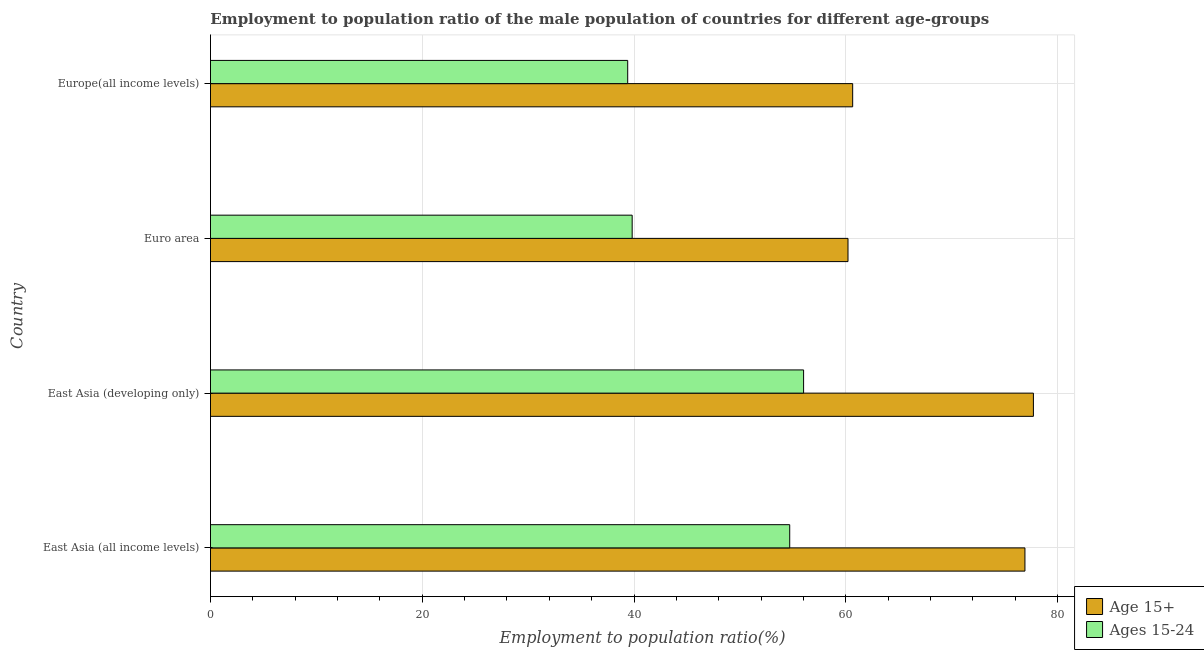How many different coloured bars are there?
Offer a very short reply. 2. Are the number of bars on each tick of the Y-axis equal?
Your answer should be very brief. Yes. How many bars are there on the 2nd tick from the bottom?
Provide a short and direct response. 2. What is the label of the 4th group of bars from the top?
Provide a succinct answer. East Asia (all income levels). In how many cases, is the number of bars for a given country not equal to the number of legend labels?
Provide a short and direct response. 0. What is the employment to population ratio(age 15+) in Euro area?
Keep it short and to the point. 60.2. Across all countries, what is the maximum employment to population ratio(age 15-24)?
Your answer should be compact. 56.01. Across all countries, what is the minimum employment to population ratio(age 15-24)?
Your response must be concise. 39.4. In which country was the employment to population ratio(age 15+) maximum?
Your response must be concise. East Asia (developing only). In which country was the employment to population ratio(age 15-24) minimum?
Offer a very short reply. Europe(all income levels). What is the total employment to population ratio(age 15-24) in the graph?
Make the answer very short. 189.93. What is the difference between the employment to population ratio(age 15+) in East Asia (all income levels) and that in Euro area?
Your answer should be compact. 16.71. What is the difference between the employment to population ratio(age 15-24) in Europe(all income levels) and the employment to population ratio(age 15+) in East Asia (all income levels)?
Ensure brevity in your answer.  -37.51. What is the average employment to population ratio(age 15-24) per country?
Your answer should be compact. 47.48. What is the difference between the employment to population ratio(age 15+) and employment to population ratio(age 15-24) in Euro area?
Provide a short and direct response. 20.38. What is the ratio of the employment to population ratio(age 15+) in East Asia (developing only) to that in Europe(all income levels)?
Provide a succinct answer. 1.28. Is the employment to population ratio(age 15-24) in East Asia (developing only) less than that in Europe(all income levels)?
Offer a terse response. No. Is the difference between the employment to population ratio(age 15+) in Euro area and Europe(all income levels) greater than the difference between the employment to population ratio(age 15-24) in Euro area and Europe(all income levels)?
Your response must be concise. No. What is the difference between the highest and the second highest employment to population ratio(age 15-24)?
Your response must be concise. 1.31. What is the difference between the highest and the lowest employment to population ratio(age 15+)?
Provide a short and direct response. 17.51. What does the 1st bar from the top in Euro area represents?
Give a very brief answer. Ages 15-24. What does the 1st bar from the bottom in Europe(all income levels) represents?
Provide a succinct answer. Age 15+. Are all the bars in the graph horizontal?
Offer a very short reply. Yes. How many countries are there in the graph?
Provide a short and direct response. 4. What is the difference between two consecutive major ticks on the X-axis?
Ensure brevity in your answer.  20. Are the values on the major ticks of X-axis written in scientific E-notation?
Your answer should be compact. No. Does the graph contain any zero values?
Offer a very short reply. No. Where does the legend appear in the graph?
Provide a short and direct response. Bottom right. How are the legend labels stacked?
Your response must be concise. Vertical. What is the title of the graph?
Provide a succinct answer. Employment to population ratio of the male population of countries for different age-groups. What is the label or title of the Y-axis?
Provide a succinct answer. Country. What is the Employment to population ratio(%) in Age 15+ in East Asia (all income levels)?
Your answer should be very brief. 76.91. What is the Employment to population ratio(%) in Ages 15-24 in East Asia (all income levels)?
Your response must be concise. 54.7. What is the Employment to population ratio(%) in Age 15+ in East Asia (developing only)?
Ensure brevity in your answer.  77.71. What is the Employment to population ratio(%) in Ages 15-24 in East Asia (developing only)?
Make the answer very short. 56.01. What is the Employment to population ratio(%) of Age 15+ in Euro area?
Your answer should be compact. 60.2. What is the Employment to population ratio(%) of Ages 15-24 in Euro area?
Your response must be concise. 39.82. What is the Employment to population ratio(%) in Age 15+ in Europe(all income levels)?
Offer a terse response. 60.65. What is the Employment to population ratio(%) of Ages 15-24 in Europe(all income levels)?
Your response must be concise. 39.4. Across all countries, what is the maximum Employment to population ratio(%) in Age 15+?
Provide a short and direct response. 77.71. Across all countries, what is the maximum Employment to population ratio(%) in Ages 15-24?
Provide a short and direct response. 56.01. Across all countries, what is the minimum Employment to population ratio(%) in Age 15+?
Ensure brevity in your answer.  60.2. Across all countries, what is the minimum Employment to population ratio(%) of Ages 15-24?
Your answer should be compact. 39.4. What is the total Employment to population ratio(%) in Age 15+ in the graph?
Your answer should be very brief. 275.47. What is the total Employment to population ratio(%) in Ages 15-24 in the graph?
Make the answer very short. 189.93. What is the difference between the Employment to population ratio(%) in Age 15+ in East Asia (all income levels) and that in East Asia (developing only)?
Offer a terse response. -0.8. What is the difference between the Employment to population ratio(%) in Ages 15-24 in East Asia (all income levels) and that in East Asia (developing only)?
Offer a terse response. -1.31. What is the difference between the Employment to population ratio(%) in Age 15+ in East Asia (all income levels) and that in Euro area?
Your answer should be very brief. 16.71. What is the difference between the Employment to population ratio(%) of Ages 15-24 in East Asia (all income levels) and that in Euro area?
Offer a terse response. 14.88. What is the difference between the Employment to population ratio(%) of Age 15+ in East Asia (all income levels) and that in Europe(all income levels)?
Ensure brevity in your answer.  16.27. What is the difference between the Employment to population ratio(%) of Ages 15-24 in East Asia (all income levels) and that in Europe(all income levels)?
Keep it short and to the point. 15.3. What is the difference between the Employment to population ratio(%) of Age 15+ in East Asia (developing only) and that in Euro area?
Make the answer very short. 17.51. What is the difference between the Employment to population ratio(%) of Ages 15-24 in East Asia (developing only) and that in Euro area?
Make the answer very short. 16.19. What is the difference between the Employment to population ratio(%) in Age 15+ in East Asia (developing only) and that in Europe(all income levels)?
Offer a terse response. 17.07. What is the difference between the Employment to population ratio(%) of Ages 15-24 in East Asia (developing only) and that in Europe(all income levels)?
Provide a succinct answer. 16.61. What is the difference between the Employment to population ratio(%) in Age 15+ in Euro area and that in Europe(all income levels)?
Ensure brevity in your answer.  -0.44. What is the difference between the Employment to population ratio(%) in Ages 15-24 in Euro area and that in Europe(all income levels)?
Your response must be concise. 0.42. What is the difference between the Employment to population ratio(%) of Age 15+ in East Asia (all income levels) and the Employment to population ratio(%) of Ages 15-24 in East Asia (developing only)?
Provide a short and direct response. 20.9. What is the difference between the Employment to population ratio(%) in Age 15+ in East Asia (all income levels) and the Employment to population ratio(%) in Ages 15-24 in Euro area?
Offer a terse response. 37.09. What is the difference between the Employment to population ratio(%) in Age 15+ in East Asia (all income levels) and the Employment to population ratio(%) in Ages 15-24 in Europe(all income levels)?
Give a very brief answer. 37.51. What is the difference between the Employment to population ratio(%) in Age 15+ in East Asia (developing only) and the Employment to population ratio(%) in Ages 15-24 in Euro area?
Your response must be concise. 37.89. What is the difference between the Employment to population ratio(%) in Age 15+ in East Asia (developing only) and the Employment to population ratio(%) in Ages 15-24 in Europe(all income levels)?
Ensure brevity in your answer.  38.31. What is the difference between the Employment to population ratio(%) of Age 15+ in Euro area and the Employment to population ratio(%) of Ages 15-24 in Europe(all income levels)?
Provide a short and direct response. 20.8. What is the average Employment to population ratio(%) in Age 15+ per country?
Your answer should be compact. 68.87. What is the average Employment to population ratio(%) in Ages 15-24 per country?
Your response must be concise. 47.48. What is the difference between the Employment to population ratio(%) of Age 15+ and Employment to population ratio(%) of Ages 15-24 in East Asia (all income levels)?
Keep it short and to the point. 22.21. What is the difference between the Employment to population ratio(%) of Age 15+ and Employment to population ratio(%) of Ages 15-24 in East Asia (developing only)?
Offer a very short reply. 21.7. What is the difference between the Employment to population ratio(%) in Age 15+ and Employment to population ratio(%) in Ages 15-24 in Euro area?
Your answer should be very brief. 20.38. What is the difference between the Employment to population ratio(%) in Age 15+ and Employment to population ratio(%) in Ages 15-24 in Europe(all income levels)?
Your response must be concise. 21.25. What is the ratio of the Employment to population ratio(%) in Ages 15-24 in East Asia (all income levels) to that in East Asia (developing only)?
Your answer should be compact. 0.98. What is the ratio of the Employment to population ratio(%) in Age 15+ in East Asia (all income levels) to that in Euro area?
Your answer should be compact. 1.28. What is the ratio of the Employment to population ratio(%) in Ages 15-24 in East Asia (all income levels) to that in Euro area?
Offer a terse response. 1.37. What is the ratio of the Employment to population ratio(%) in Age 15+ in East Asia (all income levels) to that in Europe(all income levels)?
Make the answer very short. 1.27. What is the ratio of the Employment to population ratio(%) in Ages 15-24 in East Asia (all income levels) to that in Europe(all income levels)?
Offer a very short reply. 1.39. What is the ratio of the Employment to population ratio(%) of Age 15+ in East Asia (developing only) to that in Euro area?
Your answer should be compact. 1.29. What is the ratio of the Employment to population ratio(%) in Ages 15-24 in East Asia (developing only) to that in Euro area?
Provide a short and direct response. 1.41. What is the ratio of the Employment to population ratio(%) in Age 15+ in East Asia (developing only) to that in Europe(all income levels)?
Offer a very short reply. 1.28. What is the ratio of the Employment to population ratio(%) of Ages 15-24 in East Asia (developing only) to that in Europe(all income levels)?
Make the answer very short. 1.42. What is the ratio of the Employment to population ratio(%) in Ages 15-24 in Euro area to that in Europe(all income levels)?
Ensure brevity in your answer.  1.01. What is the difference between the highest and the second highest Employment to population ratio(%) of Age 15+?
Make the answer very short. 0.8. What is the difference between the highest and the second highest Employment to population ratio(%) of Ages 15-24?
Keep it short and to the point. 1.31. What is the difference between the highest and the lowest Employment to population ratio(%) in Age 15+?
Your answer should be very brief. 17.51. What is the difference between the highest and the lowest Employment to population ratio(%) in Ages 15-24?
Make the answer very short. 16.61. 